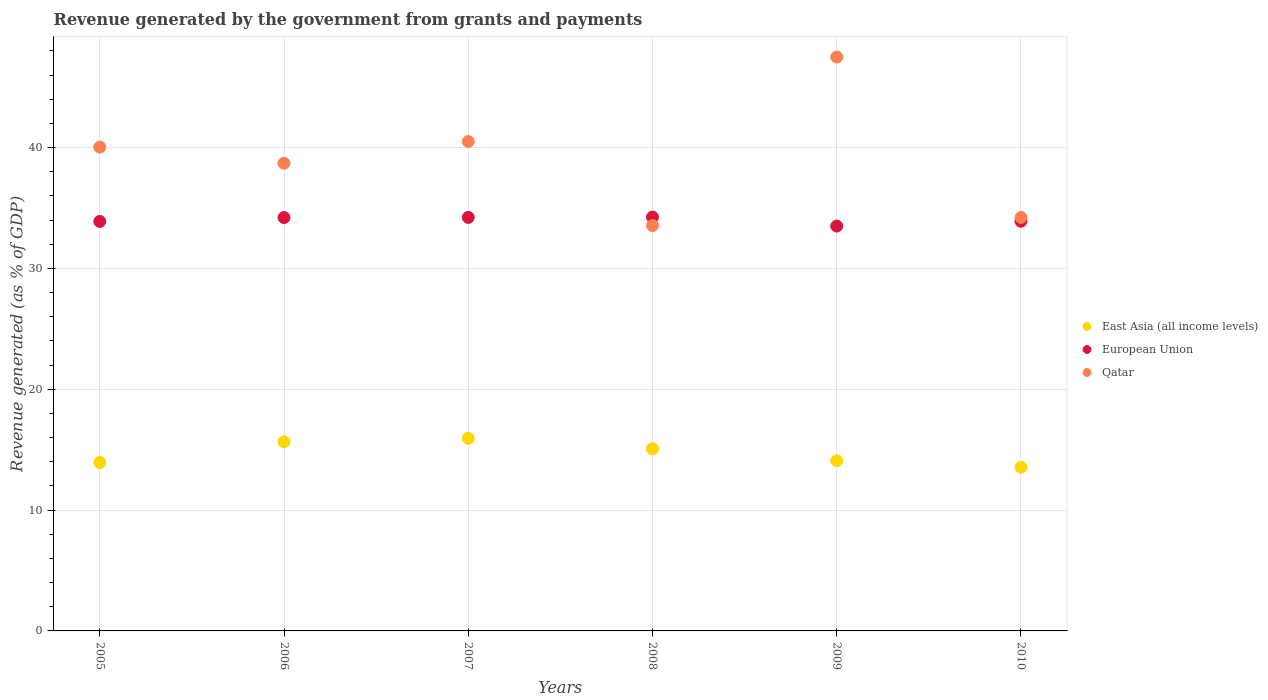How many different coloured dotlines are there?
Provide a short and direct response. 3. Is the number of dotlines equal to the number of legend labels?
Your answer should be compact. Yes. What is the revenue generated by the government in East Asia (all income levels) in 2006?
Your response must be concise. 15.65. Across all years, what is the maximum revenue generated by the government in European Union?
Your answer should be very brief. 34.25. Across all years, what is the minimum revenue generated by the government in East Asia (all income levels)?
Your answer should be compact. 13.55. What is the total revenue generated by the government in European Union in the graph?
Offer a very short reply. 204.01. What is the difference between the revenue generated by the government in East Asia (all income levels) in 2009 and that in 2010?
Offer a terse response. 0.54. What is the difference between the revenue generated by the government in Qatar in 2008 and the revenue generated by the government in European Union in 2010?
Offer a very short reply. -0.36. What is the average revenue generated by the government in European Union per year?
Provide a succinct answer. 34. In the year 2010, what is the difference between the revenue generated by the government in East Asia (all income levels) and revenue generated by the government in Qatar?
Offer a very short reply. -20.67. In how many years, is the revenue generated by the government in Qatar greater than 46 %?
Provide a succinct answer. 1. What is the ratio of the revenue generated by the government in Qatar in 2009 to that in 2010?
Provide a short and direct response. 1.39. Is the difference between the revenue generated by the government in East Asia (all income levels) in 2005 and 2006 greater than the difference between the revenue generated by the government in Qatar in 2005 and 2006?
Provide a succinct answer. No. What is the difference between the highest and the second highest revenue generated by the government in Qatar?
Provide a succinct answer. 6.99. What is the difference between the highest and the lowest revenue generated by the government in European Union?
Offer a terse response. 0.75. In how many years, is the revenue generated by the government in European Union greater than the average revenue generated by the government in European Union taken over all years?
Provide a succinct answer. 3. Is the revenue generated by the government in European Union strictly less than the revenue generated by the government in East Asia (all income levels) over the years?
Offer a terse response. No. How many dotlines are there?
Offer a very short reply. 3. What is the difference between two consecutive major ticks on the Y-axis?
Provide a short and direct response. 10. Does the graph contain any zero values?
Ensure brevity in your answer.  No. Does the graph contain grids?
Provide a succinct answer. Yes. Where does the legend appear in the graph?
Your answer should be compact. Center right. How are the legend labels stacked?
Your response must be concise. Vertical. What is the title of the graph?
Keep it short and to the point. Revenue generated by the government from grants and payments. Does "Singapore" appear as one of the legend labels in the graph?
Your answer should be very brief. No. What is the label or title of the X-axis?
Provide a succinct answer. Years. What is the label or title of the Y-axis?
Offer a terse response. Revenue generated (as % of GDP). What is the Revenue generated (as % of GDP) in East Asia (all income levels) in 2005?
Make the answer very short. 13.94. What is the Revenue generated (as % of GDP) in European Union in 2005?
Offer a very short reply. 33.89. What is the Revenue generated (as % of GDP) of Qatar in 2005?
Your response must be concise. 40.04. What is the Revenue generated (as % of GDP) in East Asia (all income levels) in 2006?
Keep it short and to the point. 15.65. What is the Revenue generated (as % of GDP) in European Union in 2006?
Your response must be concise. 34.21. What is the Revenue generated (as % of GDP) in Qatar in 2006?
Offer a very short reply. 38.71. What is the Revenue generated (as % of GDP) of East Asia (all income levels) in 2007?
Offer a very short reply. 15.94. What is the Revenue generated (as % of GDP) in European Union in 2007?
Give a very brief answer. 34.23. What is the Revenue generated (as % of GDP) in Qatar in 2007?
Give a very brief answer. 40.51. What is the Revenue generated (as % of GDP) of East Asia (all income levels) in 2008?
Ensure brevity in your answer.  15.07. What is the Revenue generated (as % of GDP) in European Union in 2008?
Make the answer very short. 34.25. What is the Revenue generated (as % of GDP) in Qatar in 2008?
Ensure brevity in your answer.  33.55. What is the Revenue generated (as % of GDP) of East Asia (all income levels) in 2009?
Your response must be concise. 14.09. What is the Revenue generated (as % of GDP) in European Union in 2009?
Keep it short and to the point. 33.51. What is the Revenue generated (as % of GDP) in Qatar in 2009?
Your response must be concise. 47.5. What is the Revenue generated (as % of GDP) of East Asia (all income levels) in 2010?
Make the answer very short. 13.55. What is the Revenue generated (as % of GDP) in European Union in 2010?
Ensure brevity in your answer.  33.91. What is the Revenue generated (as % of GDP) of Qatar in 2010?
Your answer should be very brief. 34.22. Across all years, what is the maximum Revenue generated (as % of GDP) in East Asia (all income levels)?
Provide a succinct answer. 15.94. Across all years, what is the maximum Revenue generated (as % of GDP) in European Union?
Your answer should be compact. 34.25. Across all years, what is the maximum Revenue generated (as % of GDP) in Qatar?
Your answer should be compact. 47.5. Across all years, what is the minimum Revenue generated (as % of GDP) in East Asia (all income levels)?
Offer a terse response. 13.55. Across all years, what is the minimum Revenue generated (as % of GDP) in European Union?
Ensure brevity in your answer.  33.51. Across all years, what is the minimum Revenue generated (as % of GDP) of Qatar?
Your answer should be compact. 33.55. What is the total Revenue generated (as % of GDP) in East Asia (all income levels) in the graph?
Ensure brevity in your answer.  88.25. What is the total Revenue generated (as % of GDP) of European Union in the graph?
Offer a terse response. 204.01. What is the total Revenue generated (as % of GDP) of Qatar in the graph?
Make the answer very short. 234.54. What is the difference between the Revenue generated (as % of GDP) of East Asia (all income levels) in 2005 and that in 2006?
Ensure brevity in your answer.  -1.71. What is the difference between the Revenue generated (as % of GDP) in European Union in 2005 and that in 2006?
Provide a short and direct response. -0.32. What is the difference between the Revenue generated (as % of GDP) in Qatar in 2005 and that in 2006?
Offer a very short reply. 1.33. What is the difference between the Revenue generated (as % of GDP) of East Asia (all income levels) in 2005 and that in 2007?
Your answer should be very brief. -2. What is the difference between the Revenue generated (as % of GDP) in European Union in 2005 and that in 2007?
Ensure brevity in your answer.  -0.34. What is the difference between the Revenue generated (as % of GDP) in Qatar in 2005 and that in 2007?
Make the answer very short. -0.46. What is the difference between the Revenue generated (as % of GDP) of East Asia (all income levels) in 2005 and that in 2008?
Offer a terse response. -1.13. What is the difference between the Revenue generated (as % of GDP) of European Union in 2005 and that in 2008?
Your answer should be compact. -0.36. What is the difference between the Revenue generated (as % of GDP) of Qatar in 2005 and that in 2008?
Your response must be concise. 6.49. What is the difference between the Revenue generated (as % of GDP) of East Asia (all income levels) in 2005 and that in 2009?
Provide a succinct answer. -0.15. What is the difference between the Revenue generated (as % of GDP) of European Union in 2005 and that in 2009?
Your answer should be compact. 0.38. What is the difference between the Revenue generated (as % of GDP) of Qatar in 2005 and that in 2009?
Provide a short and direct response. -7.45. What is the difference between the Revenue generated (as % of GDP) of East Asia (all income levels) in 2005 and that in 2010?
Your response must be concise. 0.39. What is the difference between the Revenue generated (as % of GDP) of European Union in 2005 and that in 2010?
Offer a very short reply. -0.02. What is the difference between the Revenue generated (as % of GDP) in Qatar in 2005 and that in 2010?
Provide a succinct answer. 5.82. What is the difference between the Revenue generated (as % of GDP) in East Asia (all income levels) in 2006 and that in 2007?
Provide a succinct answer. -0.29. What is the difference between the Revenue generated (as % of GDP) of European Union in 2006 and that in 2007?
Your answer should be compact. -0.02. What is the difference between the Revenue generated (as % of GDP) in Qatar in 2006 and that in 2007?
Provide a succinct answer. -1.8. What is the difference between the Revenue generated (as % of GDP) in East Asia (all income levels) in 2006 and that in 2008?
Ensure brevity in your answer.  0.58. What is the difference between the Revenue generated (as % of GDP) of European Union in 2006 and that in 2008?
Make the answer very short. -0.04. What is the difference between the Revenue generated (as % of GDP) in Qatar in 2006 and that in 2008?
Ensure brevity in your answer.  5.16. What is the difference between the Revenue generated (as % of GDP) in East Asia (all income levels) in 2006 and that in 2009?
Ensure brevity in your answer.  1.56. What is the difference between the Revenue generated (as % of GDP) of European Union in 2006 and that in 2009?
Offer a terse response. 0.7. What is the difference between the Revenue generated (as % of GDP) of Qatar in 2006 and that in 2009?
Provide a short and direct response. -8.78. What is the difference between the Revenue generated (as % of GDP) in East Asia (all income levels) in 2006 and that in 2010?
Offer a terse response. 2.1. What is the difference between the Revenue generated (as % of GDP) of European Union in 2006 and that in 2010?
Provide a succinct answer. 0.3. What is the difference between the Revenue generated (as % of GDP) in Qatar in 2006 and that in 2010?
Offer a terse response. 4.49. What is the difference between the Revenue generated (as % of GDP) of East Asia (all income levels) in 2007 and that in 2008?
Offer a terse response. 0.87. What is the difference between the Revenue generated (as % of GDP) of European Union in 2007 and that in 2008?
Offer a terse response. -0.03. What is the difference between the Revenue generated (as % of GDP) of Qatar in 2007 and that in 2008?
Give a very brief answer. 6.95. What is the difference between the Revenue generated (as % of GDP) of East Asia (all income levels) in 2007 and that in 2009?
Your response must be concise. 1.85. What is the difference between the Revenue generated (as % of GDP) in European Union in 2007 and that in 2009?
Provide a short and direct response. 0.72. What is the difference between the Revenue generated (as % of GDP) of Qatar in 2007 and that in 2009?
Provide a short and direct response. -6.99. What is the difference between the Revenue generated (as % of GDP) in East Asia (all income levels) in 2007 and that in 2010?
Give a very brief answer. 2.39. What is the difference between the Revenue generated (as % of GDP) of European Union in 2007 and that in 2010?
Provide a succinct answer. 0.32. What is the difference between the Revenue generated (as % of GDP) of Qatar in 2007 and that in 2010?
Make the answer very short. 6.28. What is the difference between the Revenue generated (as % of GDP) in East Asia (all income levels) in 2008 and that in 2009?
Offer a terse response. 0.99. What is the difference between the Revenue generated (as % of GDP) of European Union in 2008 and that in 2009?
Ensure brevity in your answer.  0.75. What is the difference between the Revenue generated (as % of GDP) of Qatar in 2008 and that in 2009?
Offer a very short reply. -13.94. What is the difference between the Revenue generated (as % of GDP) of East Asia (all income levels) in 2008 and that in 2010?
Ensure brevity in your answer.  1.52. What is the difference between the Revenue generated (as % of GDP) of European Union in 2008 and that in 2010?
Ensure brevity in your answer.  0.34. What is the difference between the Revenue generated (as % of GDP) of Qatar in 2008 and that in 2010?
Provide a succinct answer. -0.67. What is the difference between the Revenue generated (as % of GDP) of East Asia (all income levels) in 2009 and that in 2010?
Provide a short and direct response. 0.54. What is the difference between the Revenue generated (as % of GDP) of European Union in 2009 and that in 2010?
Provide a succinct answer. -0.4. What is the difference between the Revenue generated (as % of GDP) in Qatar in 2009 and that in 2010?
Provide a succinct answer. 13.27. What is the difference between the Revenue generated (as % of GDP) in East Asia (all income levels) in 2005 and the Revenue generated (as % of GDP) in European Union in 2006?
Your answer should be compact. -20.27. What is the difference between the Revenue generated (as % of GDP) of East Asia (all income levels) in 2005 and the Revenue generated (as % of GDP) of Qatar in 2006?
Make the answer very short. -24.77. What is the difference between the Revenue generated (as % of GDP) of European Union in 2005 and the Revenue generated (as % of GDP) of Qatar in 2006?
Offer a terse response. -4.82. What is the difference between the Revenue generated (as % of GDP) of East Asia (all income levels) in 2005 and the Revenue generated (as % of GDP) of European Union in 2007?
Give a very brief answer. -20.28. What is the difference between the Revenue generated (as % of GDP) of East Asia (all income levels) in 2005 and the Revenue generated (as % of GDP) of Qatar in 2007?
Give a very brief answer. -26.56. What is the difference between the Revenue generated (as % of GDP) of European Union in 2005 and the Revenue generated (as % of GDP) of Qatar in 2007?
Offer a very short reply. -6.62. What is the difference between the Revenue generated (as % of GDP) in East Asia (all income levels) in 2005 and the Revenue generated (as % of GDP) in European Union in 2008?
Provide a short and direct response. -20.31. What is the difference between the Revenue generated (as % of GDP) in East Asia (all income levels) in 2005 and the Revenue generated (as % of GDP) in Qatar in 2008?
Offer a very short reply. -19.61. What is the difference between the Revenue generated (as % of GDP) in European Union in 2005 and the Revenue generated (as % of GDP) in Qatar in 2008?
Your response must be concise. 0.34. What is the difference between the Revenue generated (as % of GDP) in East Asia (all income levels) in 2005 and the Revenue generated (as % of GDP) in European Union in 2009?
Offer a terse response. -19.56. What is the difference between the Revenue generated (as % of GDP) of East Asia (all income levels) in 2005 and the Revenue generated (as % of GDP) of Qatar in 2009?
Provide a short and direct response. -33.55. What is the difference between the Revenue generated (as % of GDP) of European Union in 2005 and the Revenue generated (as % of GDP) of Qatar in 2009?
Provide a succinct answer. -13.6. What is the difference between the Revenue generated (as % of GDP) in East Asia (all income levels) in 2005 and the Revenue generated (as % of GDP) in European Union in 2010?
Ensure brevity in your answer.  -19.97. What is the difference between the Revenue generated (as % of GDP) of East Asia (all income levels) in 2005 and the Revenue generated (as % of GDP) of Qatar in 2010?
Offer a terse response. -20.28. What is the difference between the Revenue generated (as % of GDP) of European Union in 2005 and the Revenue generated (as % of GDP) of Qatar in 2010?
Provide a succinct answer. -0.33. What is the difference between the Revenue generated (as % of GDP) of East Asia (all income levels) in 2006 and the Revenue generated (as % of GDP) of European Union in 2007?
Provide a succinct answer. -18.58. What is the difference between the Revenue generated (as % of GDP) in East Asia (all income levels) in 2006 and the Revenue generated (as % of GDP) in Qatar in 2007?
Offer a terse response. -24.86. What is the difference between the Revenue generated (as % of GDP) in European Union in 2006 and the Revenue generated (as % of GDP) in Qatar in 2007?
Ensure brevity in your answer.  -6.29. What is the difference between the Revenue generated (as % of GDP) of East Asia (all income levels) in 2006 and the Revenue generated (as % of GDP) of European Union in 2008?
Your answer should be very brief. -18.6. What is the difference between the Revenue generated (as % of GDP) in East Asia (all income levels) in 2006 and the Revenue generated (as % of GDP) in Qatar in 2008?
Offer a terse response. -17.9. What is the difference between the Revenue generated (as % of GDP) of European Union in 2006 and the Revenue generated (as % of GDP) of Qatar in 2008?
Make the answer very short. 0.66. What is the difference between the Revenue generated (as % of GDP) of East Asia (all income levels) in 2006 and the Revenue generated (as % of GDP) of European Union in 2009?
Provide a short and direct response. -17.86. What is the difference between the Revenue generated (as % of GDP) of East Asia (all income levels) in 2006 and the Revenue generated (as % of GDP) of Qatar in 2009?
Your response must be concise. -31.85. What is the difference between the Revenue generated (as % of GDP) in European Union in 2006 and the Revenue generated (as % of GDP) in Qatar in 2009?
Your answer should be very brief. -13.28. What is the difference between the Revenue generated (as % of GDP) in East Asia (all income levels) in 2006 and the Revenue generated (as % of GDP) in European Union in 2010?
Provide a short and direct response. -18.26. What is the difference between the Revenue generated (as % of GDP) of East Asia (all income levels) in 2006 and the Revenue generated (as % of GDP) of Qatar in 2010?
Keep it short and to the point. -18.57. What is the difference between the Revenue generated (as % of GDP) of European Union in 2006 and the Revenue generated (as % of GDP) of Qatar in 2010?
Provide a short and direct response. -0.01. What is the difference between the Revenue generated (as % of GDP) in East Asia (all income levels) in 2007 and the Revenue generated (as % of GDP) in European Union in 2008?
Provide a short and direct response. -18.31. What is the difference between the Revenue generated (as % of GDP) in East Asia (all income levels) in 2007 and the Revenue generated (as % of GDP) in Qatar in 2008?
Your response must be concise. -17.61. What is the difference between the Revenue generated (as % of GDP) of European Union in 2007 and the Revenue generated (as % of GDP) of Qatar in 2008?
Provide a succinct answer. 0.67. What is the difference between the Revenue generated (as % of GDP) of East Asia (all income levels) in 2007 and the Revenue generated (as % of GDP) of European Union in 2009?
Offer a very short reply. -17.56. What is the difference between the Revenue generated (as % of GDP) of East Asia (all income levels) in 2007 and the Revenue generated (as % of GDP) of Qatar in 2009?
Offer a terse response. -31.55. What is the difference between the Revenue generated (as % of GDP) in European Union in 2007 and the Revenue generated (as % of GDP) in Qatar in 2009?
Offer a very short reply. -13.27. What is the difference between the Revenue generated (as % of GDP) of East Asia (all income levels) in 2007 and the Revenue generated (as % of GDP) of European Union in 2010?
Your response must be concise. -17.97. What is the difference between the Revenue generated (as % of GDP) in East Asia (all income levels) in 2007 and the Revenue generated (as % of GDP) in Qatar in 2010?
Give a very brief answer. -18.28. What is the difference between the Revenue generated (as % of GDP) of European Union in 2007 and the Revenue generated (as % of GDP) of Qatar in 2010?
Your answer should be compact. 0. What is the difference between the Revenue generated (as % of GDP) of East Asia (all income levels) in 2008 and the Revenue generated (as % of GDP) of European Union in 2009?
Give a very brief answer. -18.43. What is the difference between the Revenue generated (as % of GDP) in East Asia (all income levels) in 2008 and the Revenue generated (as % of GDP) in Qatar in 2009?
Your response must be concise. -32.42. What is the difference between the Revenue generated (as % of GDP) of European Union in 2008 and the Revenue generated (as % of GDP) of Qatar in 2009?
Ensure brevity in your answer.  -13.24. What is the difference between the Revenue generated (as % of GDP) of East Asia (all income levels) in 2008 and the Revenue generated (as % of GDP) of European Union in 2010?
Provide a succinct answer. -18.84. What is the difference between the Revenue generated (as % of GDP) in East Asia (all income levels) in 2008 and the Revenue generated (as % of GDP) in Qatar in 2010?
Offer a terse response. -19.15. What is the difference between the Revenue generated (as % of GDP) of European Union in 2008 and the Revenue generated (as % of GDP) of Qatar in 2010?
Keep it short and to the point. 0.03. What is the difference between the Revenue generated (as % of GDP) of East Asia (all income levels) in 2009 and the Revenue generated (as % of GDP) of European Union in 2010?
Provide a short and direct response. -19.82. What is the difference between the Revenue generated (as % of GDP) of East Asia (all income levels) in 2009 and the Revenue generated (as % of GDP) of Qatar in 2010?
Provide a succinct answer. -20.14. What is the difference between the Revenue generated (as % of GDP) of European Union in 2009 and the Revenue generated (as % of GDP) of Qatar in 2010?
Your answer should be very brief. -0.72. What is the average Revenue generated (as % of GDP) of East Asia (all income levels) per year?
Ensure brevity in your answer.  14.71. What is the average Revenue generated (as % of GDP) of European Union per year?
Make the answer very short. 34. What is the average Revenue generated (as % of GDP) of Qatar per year?
Ensure brevity in your answer.  39.09. In the year 2005, what is the difference between the Revenue generated (as % of GDP) in East Asia (all income levels) and Revenue generated (as % of GDP) in European Union?
Your response must be concise. -19.95. In the year 2005, what is the difference between the Revenue generated (as % of GDP) in East Asia (all income levels) and Revenue generated (as % of GDP) in Qatar?
Keep it short and to the point. -26.1. In the year 2005, what is the difference between the Revenue generated (as % of GDP) in European Union and Revenue generated (as % of GDP) in Qatar?
Provide a succinct answer. -6.15. In the year 2006, what is the difference between the Revenue generated (as % of GDP) of East Asia (all income levels) and Revenue generated (as % of GDP) of European Union?
Provide a succinct answer. -18.56. In the year 2006, what is the difference between the Revenue generated (as % of GDP) of East Asia (all income levels) and Revenue generated (as % of GDP) of Qatar?
Your response must be concise. -23.06. In the year 2006, what is the difference between the Revenue generated (as % of GDP) of European Union and Revenue generated (as % of GDP) of Qatar?
Make the answer very short. -4.5. In the year 2007, what is the difference between the Revenue generated (as % of GDP) of East Asia (all income levels) and Revenue generated (as % of GDP) of European Union?
Your response must be concise. -18.28. In the year 2007, what is the difference between the Revenue generated (as % of GDP) of East Asia (all income levels) and Revenue generated (as % of GDP) of Qatar?
Provide a succinct answer. -24.56. In the year 2007, what is the difference between the Revenue generated (as % of GDP) of European Union and Revenue generated (as % of GDP) of Qatar?
Your response must be concise. -6.28. In the year 2008, what is the difference between the Revenue generated (as % of GDP) of East Asia (all income levels) and Revenue generated (as % of GDP) of European Union?
Provide a succinct answer. -19.18. In the year 2008, what is the difference between the Revenue generated (as % of GDP) in East Asia (all income levels) and Revenue generated (as % of GDP) in Qatar?
Your answer should be compact. -18.48. In the year 2008, what is the difference between the Revenue generated (as % of GDP) in European Union and Revenue generated (as % of GDP) in Qatar?
Provide a succinct answer. 0.7. In the year 2009, what is the difference between the Revenue generated (as % of GDP) of East Asia (all income levels) and Revenue generated (as % of GDP) of European Union?
Your answer should be compact. -19.42. In the year 2009, what is the difference between the Revenue generated (as % of GDP) in East Asia (all income levels) and Revenue generated (as % of GDP) in Qatar?
Your answer should be compact. -33.41. In the year 2009, what is the difference between the Revenue generated (as % of GDP) of European Union and Revenue generated (as % of GDP) of Qatar?
Provide a short and direct response. -13.99. In the year 2010, what is the difference between the Revenue generated (as % of GDP) of East Asia (all income levels) and Revenue generated (as % of GDP) of European Union?
Keep it short and to the point. -20.36. In the year 2010, what is the difference between the Revenue generated (as % of GDP) in East Asia (all income levels) and Revenue generated (as % of GDP) in Qatar?
Ensure brevity in your answer.  -20.67. In the year 2010, what is the difference between the Revenue generated (as % of GDP) of European Union and Revenue generated (as % of GDP) of Qatar?
Give a very brief answer. -0.31. What is the ratio of the Revenue generated (as % of GDP) of East Asia (all income levels) in 2005 to that in 2006?
Offer a very short reply. 0.89. What is the ratio of the Revenue generated (as % of GDP) in European Union in 2005 to that in 2006?
Your answer should be very brief. 0.99. What is the ratio of the Revenue generated (as % of GDP) in Qatar in 2005 to that in 2006?
Offer a terse response. 1.03. What is the ratio of the Revenue generated (as % of GDP) in East Asia (all income levels) in 2005 to that in 2007?
Give a very brief answer. 0.87. What is the ratio of the Revenue generated (as % of GDP) in European Union in 2005 to that in 2007?
Give a very brief answer. 0.99. What is the ratio of the Revenue generated (as % of GDP) in Qatar in 2005 to that in 2007?
Your answer should be very brief. 0.99. What is the ratio of the Revenue generated (as % of GDP) in East Asia (all income levels) in 2005 to that in 2008?
Make the answer very short. 0.93. What is the ratio of the Revenue generated (as % of GDP) in European Union in 2005 to that in 2008?
Your answer should be very brief. 0.99. What is the ratio of the Revenue generated (as % of GDP) of Qatar in 2005 to that in 2008?
Your answer should be compact. 1.19. What is the ratio of the Revenue generated (as % of GDP) in East Asia (all income levels) in 2005 to that in 2009?
Provide a succinct answer. 0.99. What is the ratio of the Revenue generated (as % of GDP) in European Union in 2005 to that in 2009?
Provide a succinct answer. 1.01. What is the ratio of the Revenue generated (as % of GDP) in Qatar in 2005 to that in 2009?
Provide a short and direct response. 0.84. What is the ratio of the Revenue generated (as % of GDP) of East Asia (all income levels) in 2005 to that in 2010?
Provide a succinct answer. 1.03. What is the ratio of the Revenue generated (as % of GDP) in European Union in 2005 to that in 2010?
Your answer should be very brief. 1. What is the ratio of the Revenue generated (as % of GDP) of Qatar in 2005 to that in 2010?
Keep it short and to the point. 1.17. What is the ratio of the Revenue generated (as % of GDP) of East Asia (all income levels) in 2006 to that in 2007?
Provide a short and direct response. 0.98. What is the ratio of the Revenue generated (as % of GDP) in Qatar in 2006 to that in 2007?
Offer a terse response. 0.96. What is the ratio of the Revenue generated (as % of GDP) in East Asia (all income levels) in 2006 to that in 2008?
Keep it short and to the point. 1.04. What is the ratio of the Revenue generated (as % of GDP) in Qatar in 2006 to that in 2008?
Offer a very short reply. 1.15. What is the ratio of the Revenue generated (as % of GDP) of East Asia (all income levels) in 2006 to that in 2009?
Your answer should be compact. 1.11. What is the ratio of the Revenue generated (as % of GDP) in Qatar in 2006 to that in 2009?
Your response must be concise. 0.82. What is the ratio of the Revenue generated (as % of GDP) of East Asia (all income levels) in 2006 to that in 2010?
Offer a very short reply. 1.15. What is the ratio of the Revenue generated (as % of GDP) of European Union in 2006 to that in 2010?
Offer a terse response. 1.01. What is the ratio of the Revenue generated (as % of GDP) of Qatar in 2006 to that in 2010?
Give a very brief answer. 1.13. What is the ratio of the Revenue generated (as % of GDP) in East Asia (all income levels) in 2007 to that in 2008?
Offer a very short reply. 1.06. What is the ratio of the Revenue generated (as % of GDP) of European Union in 2007 to that in 2008?
Your answer should be very brief. 1. What is the ratio of the Revenue generated (as % of GDP) of Qatar in 2007 to that in 2008?
Offer a very short reply. 1.21. What is the ratio of the Revenue generated (as % of GDP) of East Asia (all income levels) in 2007 to that in 2009?
Give a very brief answer. 1.13. What is the ratio of the Revenue generated (as % of GDP) in European Union in 2007 to that in 2009?
Your answer should be very brief. 1.02. What is the ratio of the Revenue generated (as % of GDP) of Qatar in 2007 to that in 2009?
Keep it short and to the point. 0.85. What is the ratio of the Revenue generated (as % of GDP) of East Asia (all income levels) in 2007 to that in 2010?
Your answer should be compact. 1.18. What is the ratio of the Revenue generated (as % of GDP) in European Union in 2007 to that in 2010?
Offer a very short reply. 1.01. What is the ratio of the Revenue generated (as % of GDP) of Qatar in 2007 to that in 2010?
Offer a terse response. 1.18. What is the ratio of the Revenue generated (as % of GDP) of East Asia (all income levels) in 2008 to that in 2009?
Provide a succinct answer. 1.07. What is the ratio of the Revenue generated (as % of GDP) of European Union in 2008 to that in 2009?
Make the answer very short. 1.02. What is the ratio of the Revenue generated (as % of GDP) of Qatar in 2008 to that in 2009?
Your response must be concise. 0.71. What is the ratio of the Revenue generated (as % of GDP) of East Asia (all income levels) in 2008 to that in 2010?
Keep it short and to the point. 1.11. What is the ratio of the Revenue generated (as % of GDP) of European Union in 2008 to that in 2010?
Offer a terse response. 1.01. What is the ratio of the Revenue generated (as % of GDP) in Qatar in 2008 to that in 2010?
Keep it short and to the point. 0.98. What is the ratio of the Revenue generated (as % of GDP) in East Asia (all income levels) in 2009 to that in 2010?
Your answer should be compact. 1.04. What is the ratio of the Revenue generated (as % of GDP) in European Union in 2009 to that in 2010?
Make the answer very short. 0.99. What is the ratio of the Revenue generated (as % of GDP) in Qatar in 2009 to that in 2010?
Keep it short and to the point. 1.39. What is the difference between the highest and the second highest Revenue generated (as % of GDP) of East Asia (all income levels)?
Your response must be concise. 0.29. What is the difference between the highest and the second highest Revenue generated (as % of GDP) of European Union?
Keep it short and to the point. 0.03. What is the difference between the highest and the second highest Revenue generated (as % of GDP) in Qatar?
Give a very brief answer. 6.99. What is the difference between the highest and the lowest Revenue generated (as % of GDP) of East Asia (all income levels)?
Make the answer very short. 2.39. What is the difference between the highest and the lowest Revenue generated (as % of GDP) in European Union?
Offer a terse response. 0.75. What is the difference between the highest and the lowest Revenue generated (as % of GDP) in Qatar?
Keep it short and to the point. 13.94. 